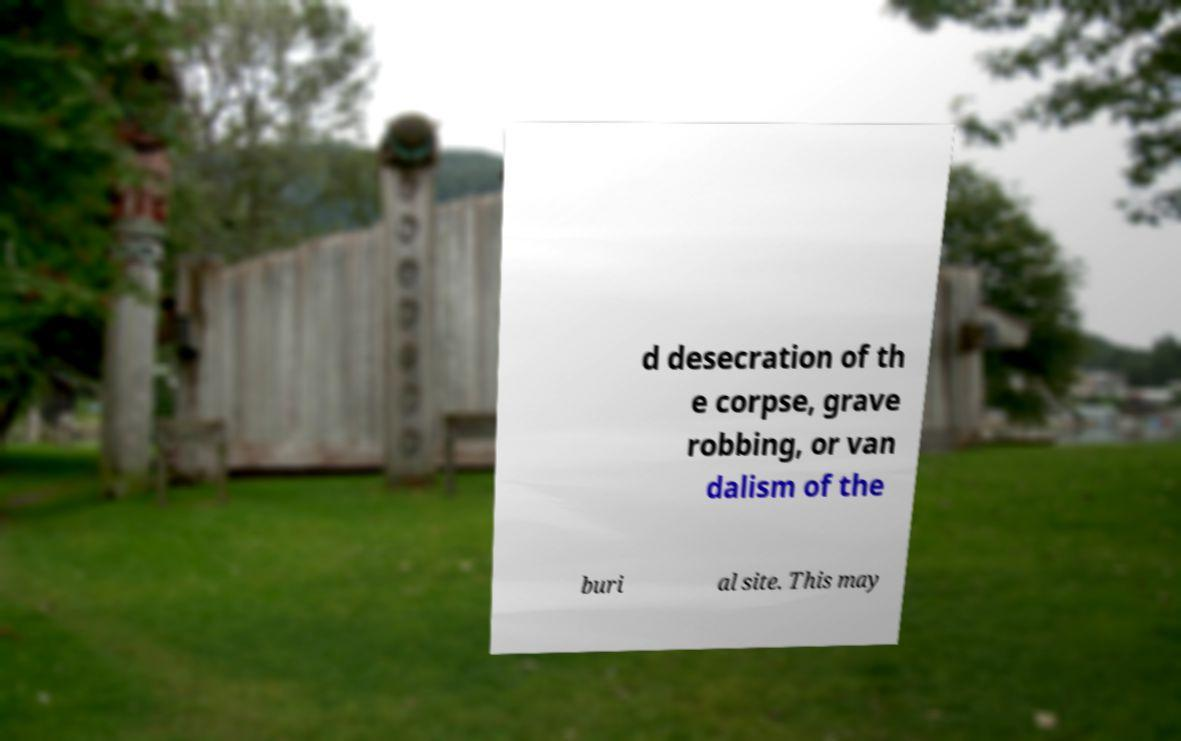Can you read and provide the text displayed in the image?This photo seems to have some interesting text. Can you extract and type it out for me? d desecration of th e corpse, grave robbing, or van dalism of the buri al site. This may 